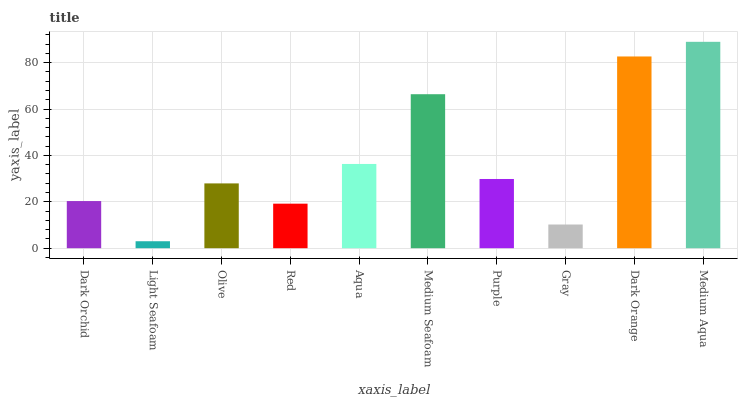Is Light Seafoam the minimum?
Answer yes or no. Yes. Is Medium Aqua the maximum?
Answer yes or no. Yes. Is Olive the minimum?
Answer yes or no. No. Is Olive the maximum?
Answer yes or no. No. Is Olive greater than Light Seafoam?
Answer yes or no. Yes. Is Light Seafoam less than Olive?
Answer yes or no. Yes. Is Light Seafoam greater than Olive?
Answer yes or no. No. Is Olive less than Light Seafoam?
Answer yes or no. No. Is Purple the high median?
Answer yes or no. Yes. Is Olive the low median?
Answer yes or no. Yes. Is Medium Seafoam the high median?
Answer yes or no. No. Is Purple the low median?
Answer yes or no. No. 